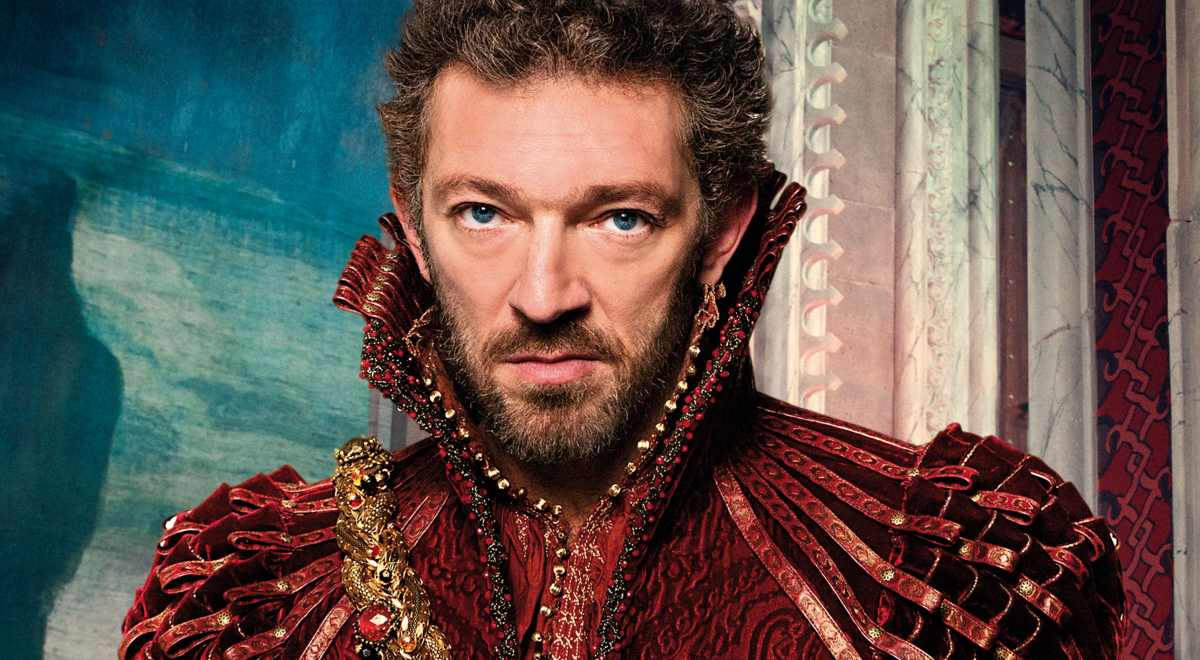Analyze the image in a comprehensive and detailed manner. In this image, we see a man with an intense gaze that commands attention. He is dressed in a luxurious costume of red and gold, featuring intricate designs and a high collar adorned with ornate embellishments. The contrast between his outfit and the rich blue background creates a visually striking composition. He stands in front of a window with partially drawn white curtains, and behind him, a richly decorated wall with red and gold patterns adds to the opulent atmosphere. His serious expression, with eyes that meet the viewer directly, adds a profound depth to the overall imagery, making it a captivating and dynamic portrait. 